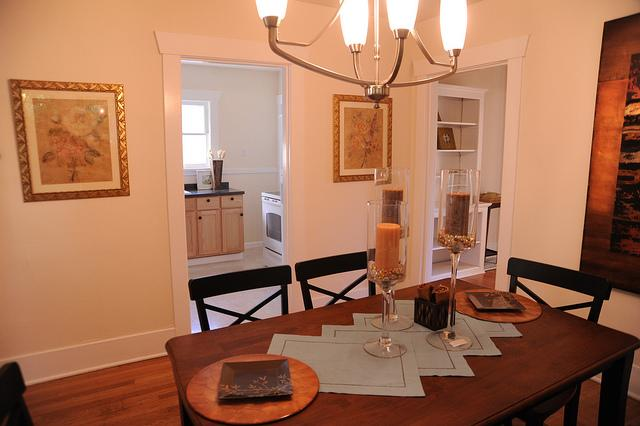What is inside the tall glasses? Please explain your reasoning. candles. There are candles sitting inside of the tall glass. 